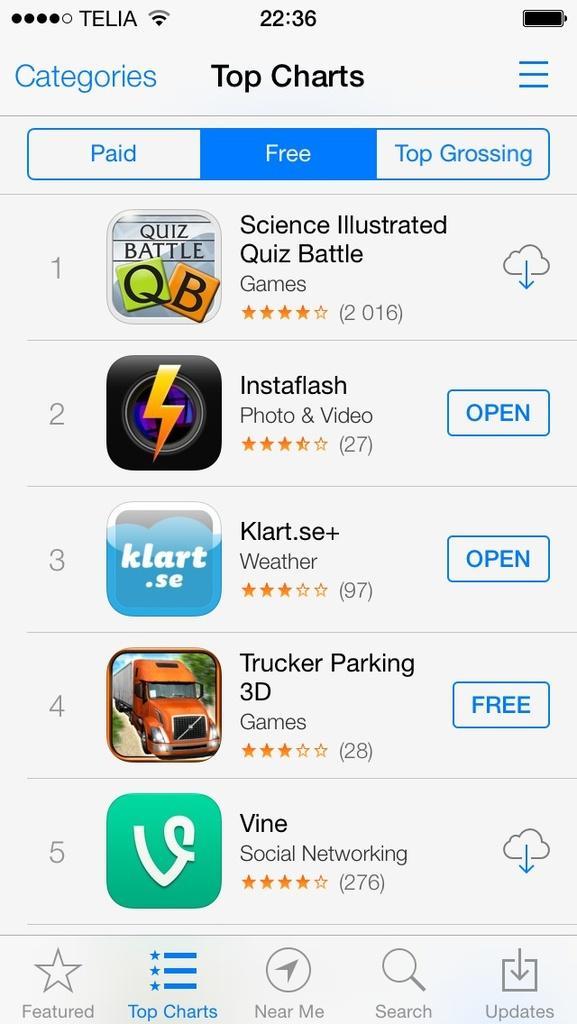Describe this image in one or two sentences. This is a web page and here we can see apps and some text. 